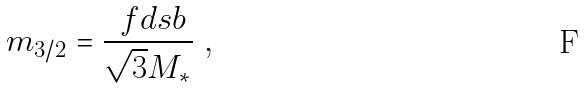<formula> <loc_0><loc_0><loc_500><loc_500>m _ { 3 / 2 } = \frac { \ f d s b } { \sqrt { 3 } M _ { * } } \ ,</formula> 